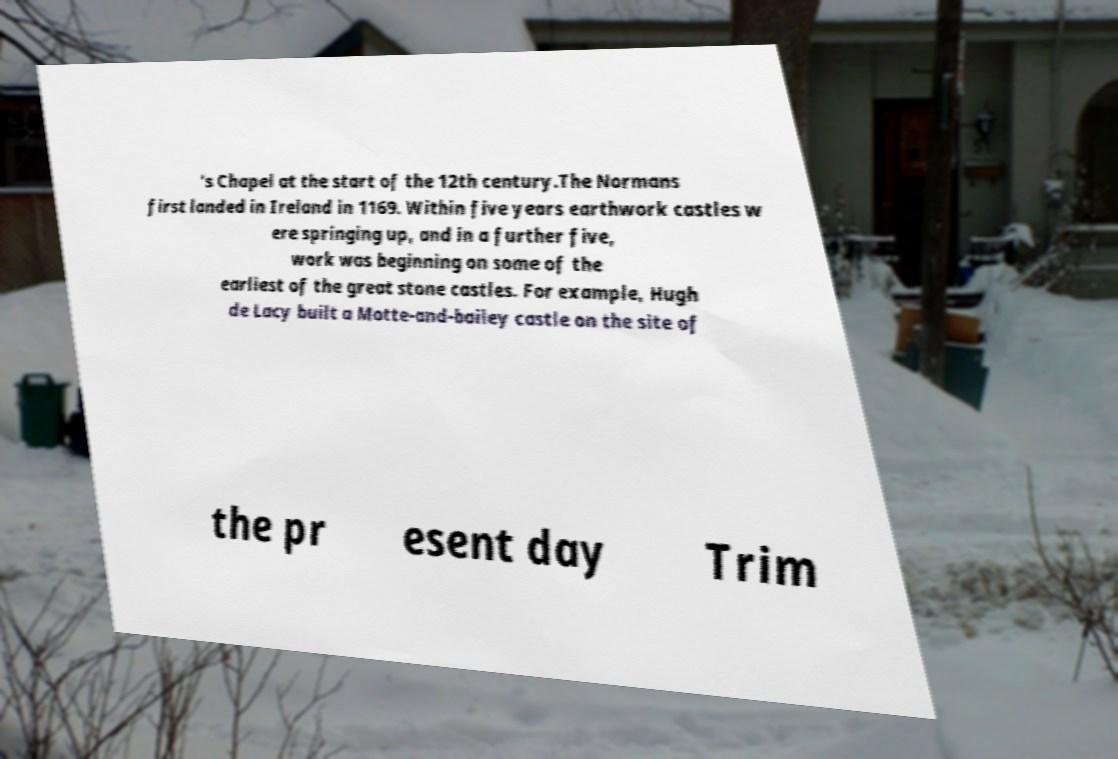There's text embedded in this image that I need extracted. Can you transcribe it verbatim? 's Chapel at the start of the 12th century.The Normans first landed in Ireland in 1169. Within five years earthwork castles w ere springing up, and in a further five, work was beginning on some of the earliest of the great stone castles. For example, Hugh de Lacy built a Motte-and-bailey castle on the site of the pr esent day Trim 